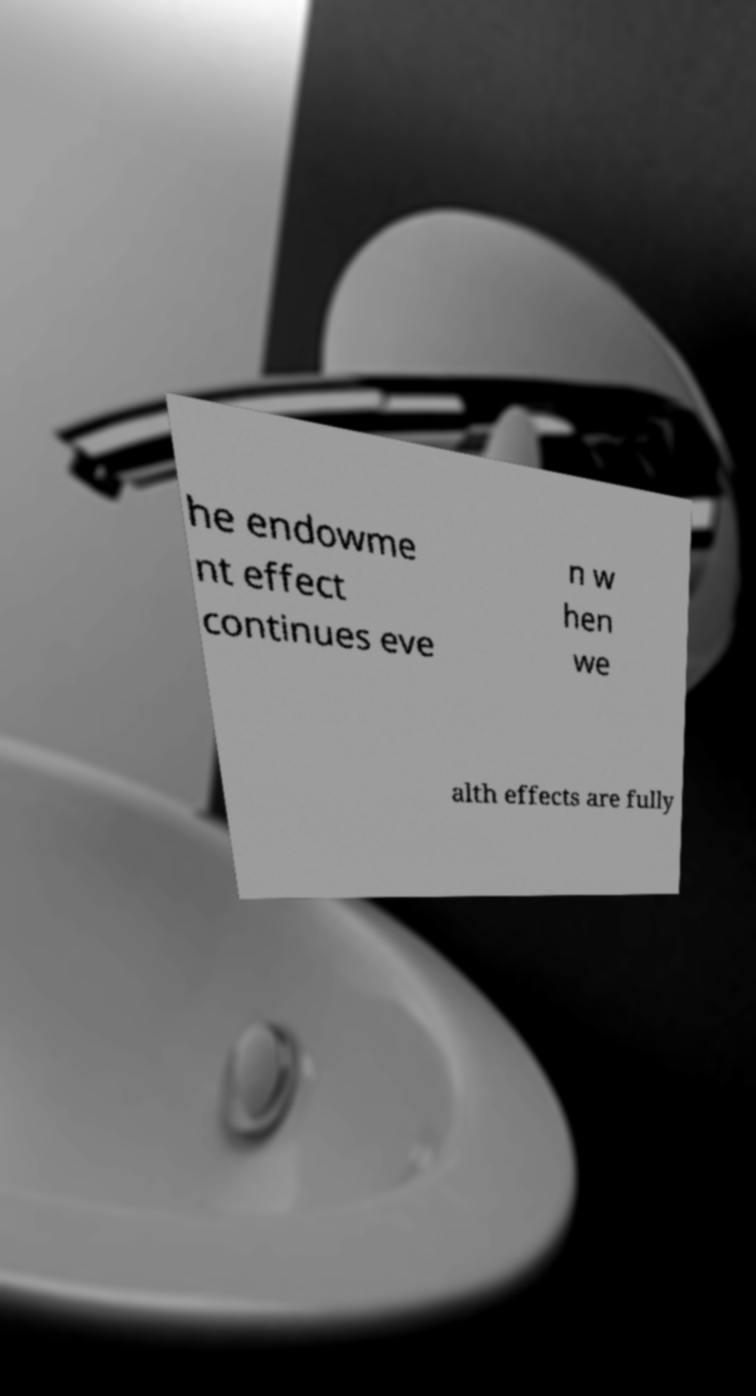I need the written content from this picture converted into text. Can you do that? he endowme nt effect continues eve n w hen we alth effects are fully 